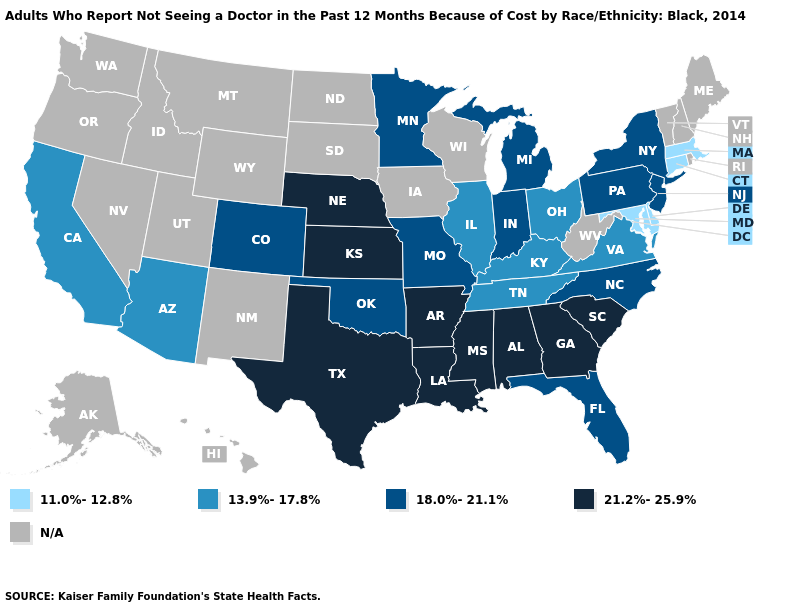What is the value of Mississippi?
Short answer required. 21.2%-25.9%. What is the lowest value in states that border New Mexico?
Answer briefly. 13.9%-17.8%. What is the lowest value in states that border Nebraska?
Quick response, please. 18.0%-21.1%. What is the value of South Carolina?
Keep it brief. 21.2%-25.9%. What is the highest value in states that border North Carolina?
Concise answer only. 21.2%-25.9%. Does Connecticut have the lowest value in the Northeast?
Write a very short answer. Yes. What is the value of Kentucky?
Keep it brief. 13.9%-17.8%. Name the states that have a value in the range N/A?
Answer briefly. Alaska, Hawaii, Idaho, Iowa, Maine, Montana, Nevada, New Hampshire, New Mexico, North Dakota, Oregon, Rhode Island, South Dakota, Utah, Vermont, Washington, West Virginia, Wisconsin, Wyoming. Does New York have the lowest value in the USA?
Keep it brief. No. Does Kansas have the highest value in the MidWest?
Answer briefly. Yes. Name the states that have a value in the range 21.2%-25.9%?
Answer briefly. Alabama, Arkansas, Georgia, Kansas, Louisiana, Mississippi, Nebraska, South Carolina, Texas. Which states hav the highest value in the MidWest?
Give a very brief answer. Kansas, Nebraska. What is the value of Idaho?
Keep it brief. N/A. Which states have the lowest value in the Northeast?
Give a very brief answer. Connecticut, Massachusetts. 